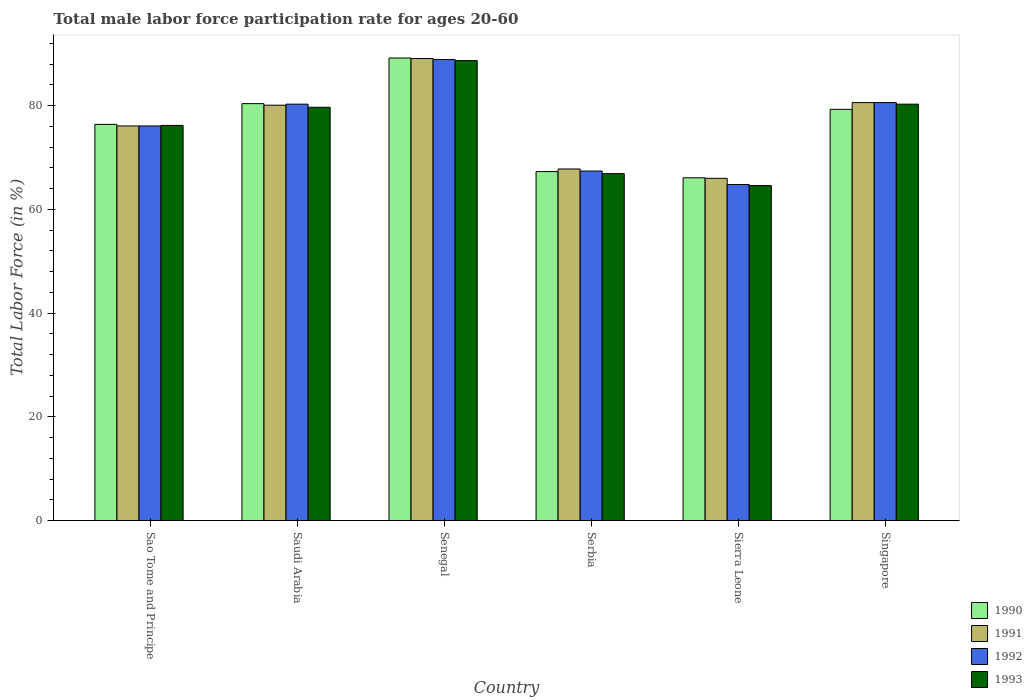Are the number of bars on each tick of the X-axis equal?
Ensure brevity in your answer.  Yes. What is the label of the 5th group of bars from the left?
Give a very brief answer. Sierra Leone. What is the male labor force participation rate in 1991 in Singapore?
Offer a very short reply. 80.6. Across all countries, what is the maximum male labor force participation rate in 1991?
Your answer should be compact. 89.1. Across all countries, what is the minimum male labor force participation rate in 1990?
Your answer should be compact. 66.1. In which country was the male labor force participation rate in 1990 maximum?
Keep it short and to the point. Senegal. In which country was the male labor force participation rate in 1993 minimum?
Make the answer very short. Sierra Leone. What is the total male labor force participation rate in 1993 in the graph?
Ensure brevity in your answer.  456.4. What is the difference between the male labor force participation rate in 1991 in Sao Tome and Principe and that in Sierra Leone?
Make the answer very short. 10.1. What is the difference between the male labor force participation rate in 1991 in Saudi Arabia and the male labor force participation rate in 1993 in Serbia?
Your answer should be very brief. 13.2. What is the average male labor force participation rate in 1993 per country?
Your answer should be compact. 76.07. What is the difference between the male labor force participation rate of/in 1990 and male labor force participation rate of/in 1991 in Singapore?
Ensure brevity in your answer.  -1.3. In how many countries, is the male labor force participation rate in 1992 greater than 56 %?
Your answer should be very brief. 6. What is the ratio of the male labor force participation rate in 1991 in Saudi Arabia to that in Serbia?
Your answer should be compact. 1.18. What is the difference between the highest and the second highest male labor force participation rate in 1993?
Provide a short and direct response. 8.4. What is the difference between the highest and the lowest male labor force participation rate in 1993?
Offer a very short reply. 24.1. In how many countries, is the male labor force participation rate in 1990 greater than the average male labor force participation rate in 1990 taken over all countries?
Give a very brief answer. 3. What does the 4th bar from the left in Singapore represents?
Make the answer very short. 1993. What does the 2nd bar from the right in Sierra Leone represents?
Offer a terse response. 1992. How many countries are there in the graph?
Provide a short and direct response. 6. What is the difference between two consecutive major ticks on the Y-axis?
Offer a terse response. 20. Are the values on the major ticks of Y-axis written in scientific E-notation?
Your answer should be very brief. No. Does the graph contain any zero values?
Your answer should be very brief. No. How many legend labels are there?
Provide a succinct answer. 4. How are the legend labels stacked?
Give a very brief answer. Vertical. What is the title of the graph?
Give a very brief answer. Total male labor force participation rate for ages 20-60. What is the label or title of the Y-axis?
Your response must be concise. Total Labor Force (in %). What is the Total Labor Force (in %) in 1990 in Sao Tome and Principe?
Provide a short and direct response. 76.4. What is the Total Labor Force (in %) in 1991 in Sao Tome and Principe?
Offer a terse response. 76.1. What is the Total Labor Force (in %) of 1992 in Sao Tome and Principe?
Offer a terse response. 76.1. What is the Total Labor Force (in %) in 1993 in Sao Tome and Principe?
Your answer should be very brief. 76.2. What is the Total Labor Force (in %) in 1990 in Saudi Arabia?
Provide a succinct answer. 80.4. What is the Total Labor Force (in %) of 1991 in Saudi Arabia?
Offer a very short reply. 80.1. What is the Total Labor Force (in %) of 1992 in Saudi Arabia?
Your answer should be very brief. 80.3. What is the Total Labor Force (in %) in 1993 in Saudi Arabia?
Offer a terse response. 79.7. What is the Total Labor Force (in %) in 1990 in Senegal?
Offer a terse response. 89.2. What is the Total Labor Force (in %) of 1991 in Senegal?
Your response must be concise. 89.1. What is the Total Labor Force (in %) of 1992 in Senegal?
Make the answer very short. 88.9. What is the Total Labor Force (in %) in 1993 in Senegal?
Make the answer very short. 88.7. What is the Total Labor Force (in %) of 1990 in Serbia?
Keep it short and to the point. 67.3. What is the Total Labor Force (in %) in 1991 in Serbia?
Offer a very short reply. 67.8. What is the Total Labor Force (in %) of 1992 in Serbia?
Make the answer very short. 67.4. What is the Total Labor Force (in %) in 1993 in Serbia?
Your response must be concise. 66.9. What is the Total Labor Force (in %) of 1990 in Sierra Leone?
Offer a terse response. 66.1. What is the Total Labor Force (in %) of 1992 in Sierra Leone?
Your answer should be compact. 64.8. What is the Total Labor Force (in %) in 1993 in Sierra Leone?
Ensure brevity in your answer.  64.6. What is the Total Labor Force (in %) in 1990 in Singapore?
Offer a very short reply. 79.3. What is the Total Labor Force (in %) of 1991 in Singapore?
Your answer should be very brief. 80.6. What is the Total Labor Force (in %) of 1992 in Singapore?
Your answer should be compact. 80.6. What is the Total Labor Force (in %) in 1993 in Singapore?
Your response must be concise. 80.3. Across all countries, what is the maximum Total Labor Force (in %) of 1990?
Offer a terse response. 89.2. Across all countries, what is the maximum Total Labor Force (in %) of 1991?
Provide a short and direct response. 89.1. Across all countries, what is the maximum Total Labor Force (in %) in 1992?
Provide a short and direct response. 88.9. Across all countries, what is the maximum Total Labor Force (in %) in 1993?
Provide a short and direct response. 88.7. Across all countries, what is the minimum Total Labor Force (in %) in 1990?
Make the answer very short. 66.1. Across all countries, what is the minimum Total Labor Force (in %) in 1991?
Keep it short and to the point. 66. Across all countries, what is the minimum Total Labor Force (in %) of 1992?
Your answer should be compact. 64.8. Across all countries, what is the minimum Total Labor Force (in %) in 1993?
Give a very brief answer. 64.6. What is the total Total Labor Force (in %) of 1990 in the graph?
Offer a terse response. 458.7. What is the total Total Labor Force (in %) in 1991 in the graph?
Provide a short and direct response. 459.7. What is the total Total Labor Force (in %) in 1992 in the graph?
Provide a short and direct response. 458.1. What is the total Total Labor Force (in %) in 1993 in the graph?
Ensure brevity in your answer.  456.4. What is the difference between the Total Labor Force (in %) of 1990 in Sao Tome and Principe and that in Saudi Arabia?
Your answer should be compact. -4. What is the difference between the Total Labor Force (in %) in 1991 in Sao Tome and Principe and that in Senegal?
Give a very brief answer. -13. What is the difference between the Total Labor Force (in %) of 1992 in Sao Tome and Principe and that in Senegal?
Your response must be concise. -12.8. What is the difference between the Total Labor Force (in %) in 1993 in Sao Tome and Principe and that in Senegal?
Make the answer very short. -12.5. What is the difference between the Total Labor Force (in %) of 1990 in Sao Tome and Principe and that in Serbia?
Give a very brief answer. 9.1. What is the difference between the Total Labor Force (in %) in 1991 in Sao Tome and Principe and that in Serbia?
Your answer should be very brief. 8.3. What is the difference between the Total Labor Force (in %) of 1993 in Sao Tome and Principe and that in Serbia?
Offer a very short reply. 9.3. What is the difference between the Total Labor Force (in %) in 1990 in Sao Tome and Principe and that in Singapore?
Offer a terse response. -2.9. What is the difference between the Total Labor Force (in %) in 1993 in Sao Tome and Principe and that in Singapore?
Ensure brevity in your answer.  -4.1. What is the difference between the Total Labor Force (in %) of 1990 in Saudi Arabia and that in Senegal?
Provide a short and direct response. -8.8. What is the difference between the Total Labor Force (in %) in 1992 in Saudi Arabia and that in Senegal?
Provide a short and direct response. -8.6. What is the difference between the Total Labor Force (in %) of 1993 in Saudi Arabia and that in Senegal?
Your response must be concise. -9. What is the difference between the Total Labor Force (in %) in 1992 in Saudi Arabia and that in Serbia?
Offer a terse response. 12.9. What is the difference between the Total Labor Force (in %) in 1993 in Saudi Arabia and that in Serbia?
Offer a very short reply. 12.8. What is the difference between the Total Labor Force (in %) of 1990 in Saudi Arabia and that in Sierra Leone?
Offer a terse response. 14.3. What is the difference between the Total Labor Force (in %) of 1992 in Saudi Arabia and that in Sierra Leone?
Your answer should be very brief. 15.5. What is the difference between the Total Labor Force (in %) of 1991 in Saudi Arabia and that in Singapore?
Provide a succinct answer. -0.5. What is the difference between the Total Labor Force (in %) of 1990 in Senegal and that in Serbia?
Provide a short and direct response. 21.9. What is the difference between the Total Labor Force (in %) in 1991 in Senegal and that in Serbia?
Give a very brief answer. 21.3. What is the difference between the Total Labor Force (in %) in 1993 in Senegal and that in Serbia?
Your answer should be compact. 21.8. What is the difference between the Total Labor Force (in %) of 1990 in Senegal and that in Sierra Leone?
Your answer should be very brief. 23.1. What is the difference between the Total Labor Force (in %) of 1991 in Senegal and that in Sierra Leone?
Your response must be concise. 23.1. What is the difference between the Total Labor Force (in %) of 1992 in Senegal and that in Sierra Leone?
Your answer should be very brief. 24.1. What is the difference between the Total Labor Force (in %) in 1993 in Senegal and that in Sierra Leone?
Offer a terse response. 24.1. What is the difference between the Total Labor Force (in %) in 1990 in Serbia and that in Sierra Leone?
Offer a very short reply. 1.2. What is the difference between the Total Labor Force (in %) of 1992 in Serbia and that in Sierra Leone?
Give a very brief answer. 2.6. What is the difference between the Total Labor Force (in %) in 1993 in Serbia and that in Sierra Leone?
Offer a terse response. 2.3. What is the difference between the Total Labor Force (in %) of 1992 in Serbia and that in Singapore?
Your answer should be very brief. -13.2. What is the difference between the Total Labor Force (in %) in 1993 in Serbia and that in Singapore?
Provide a short and direct response. -13.4. What is the difference between the Total Labor Force (in %) of 1990 in Sierra Leone and that in Singapore?
Keep it short and to the point. -13.2. What is the difference between the Total Labor Force (in %) in 1991 in Sierra Leone and that in Singapore?
Your answer should be very brief. -14.6. What is the difference between the Total Labor Force (in %) of 1992 in Sierra Leone and that in Singapore?
Provide a short and direct response. -15.8. What is the difference between the Total Labor Force (in %) of 1993 in Sierra Leone and that in Singapore?
Provide a succinct answer. -15.7. What is the difference between the Total Labor Force (in %) of 1990 in Sao Tome and Principe and the Total Labor Force (in %) of 1993 in Saudi Arabia?
Keep it short and to the point. -3.3. What is the difference between the Total Labor Force (in %) of 1992 in Sao Tome and Principe and the Total Labor Force (in %) of 1993 in Saudi Arabia?
Your answer should be compact. -3.6. What is the difference between the Total Labor Force (in %) in 1990 in Sao Tome and Principe and the Total Labor Force (in %) in 1992 in Senegal?
Offer a terse response. -12.5. What is the difference between the Total Labor Force (in %) of 1991 in Sao Tome and Principe and the Total Labor Force (in %) of 1993 in Senegal?
Your answer should be compact. -12.6. What is the difference between the Total Labor Force (in %) in 1992 in Sao Tome and Principe and the Total Labor Force (in %) in 1993 in Senegal?
Make the answer very short. -12.6. What is the difference between the Total Labor Force (in %) in 1990 in Sao Tome and Principe and the Total Labor Force (in %) in 1992 in Serbia?
Offer a terse response. 9. What is the difference between the Total Labor Force (in %) of 1990 in Sao Tome and Principe and the Total Labor Force (in %) of 1993 in Serbia?
Your answer should be compact. 9.5. What is the difference between the Total Labor Force (in %) in 1991 in Sao Tome and Principe and the Total Labor Force (in %) in 1992 in Serbia?
Provide a succinct answer. 8.7. What is the difference between the Total Labor Force (in %) in 1992 in Sao Tome and Principe and the Total Labor Force (in %) in 1993 in Serbia?
Keep it short and to the point. 9.2. What is the difference between the Total Labor Force (in %) of 1990 in Sao Tome and Principe and the Total Labor Force (in %) of 1991 in Sierra Leone?
Your answer should be compact. 10.4. What is the difference between the Total Labor Force (in %) in 1990 in Sao Tome and Principe and the Total Labor Force (in %) in 1993 in Sierra Leone?
Offer a terse response. 11.8. What is the difference between the Total Labor Force (in %) of 1990 in Sao Tome and Principe and the Total Labor Force (in %) of 1991 in Singapore?
Your answer should be compact. -4.2. What is the difference between the Total Labor Force (in %) in 1990 in Sao Tome and Principe and the Total Labor Force (in %) in 1993 in Singapore?
Your answer should be very brief. -3.9. What is the difference between the Total Labor Force (in %) of 1991 in Sao Tome and Principe and the Total Labor Force (in %) of 1992 in Singapore?
Offer a terse response. -4.5. What is the difference between the Total Labor Force (in %) in 1990 in Saudi Arabia and the Total Labor Force (in %) in 1991 in Senegal?
Make the answer very short. -8.7. What is the difference between the Total Labor Force (in %) of 1990 in Saudi Arabia and the Total Labor Force (in %) of 1992 in Senegal?
Offer a very short reply. -8.5. What is the difference between the Total Labor Force (in %) in 1990 in Saudi Arabia and the Total Labor Force (in %) in 1993 in Senegal?
Your response must be concise. -8.3. What is the difference between the Total Labor Force (in %) of 1990 in Saudi Arabia and the Total Labor Force (in %) of 1991 in Serbia?
Your answer should be very brief. 12.6. What is the difference between the Total Labor Force (in %) of 1990 in Saudi Arabia and the Total Labor Force (in %) of 1993 in Serbia?
Provide a short and direct response. 13.5. What is the difference between the Total Labor Force (in %) in 1991 in Saudi Arabia and the Total Labor Force (in %) in 1992 in Serbia?
Make the answer very short. 12.7. What is the difference between the Total Labor Force (in %) in 1992 in Saudi Arabia and the Total Labor Force (in %) in 1993 in Serbia?
Your answer should be compact. 13.4. What is the difference between the Total Labor Force (in %) of 1990 in Saudi Arabia and the Total Labor Force (in %) of 1991 in Sierra Leone?
Keep it short and to the point. 14.4. What is the difference between the Total Labor Force (in %) in 1990 in Saudi Arabia and the Total Labor Force (in %) in 1992 in Sierra Leone?
Provide a succinct answer. 15.6. What is the difference between the Total Labor Force (in %) of 1991 in Saudi Arabia and the Total Labor Force (in %) of 1992 in Sierra Leone?
Provide a succinct answer. 15.3. What is the difference between the Total Labor Force (in %) in 1991 in Saudi Arabia and the Total Labor Force (in %) in 1993 in Sierra Leone?
Your answer should be compact. 15.5. What is the difference between the Total Labor Force (in %) in 1990 in Saudi Arabia and the Total Labor Force (in %) in 1992 in Singapore?
Your answer should be compact. -0.2. What is the difference between the Total Labor Force (in %) of 1990 in Saudi Arabia and the Total Labor Force (in %) of 1993 in Singapore?
Provide a short and direct response. 0.1. What is the difference between the Total Labor Force (in %) in 1990 in Senegal and the Total Labor Force (in %) in 1991 in Serbia?
Offer a very short reply. 21.4. What is the difference between the Total Labor Force (in %) of 1990 in Senegal and the Total Labor Force (in %) of 1992 in Serbia?
Offer a very short reply. 21.8. What is the difference between the Total Labor Force (in %) of 1990 in Senegal and the Total Labor Force (in %) of 1993 in Serbia?
Make the answer very short. 22.3. What is the difference between the Total Labor Force (in %) in 1991 in Senegal and the Total Labor Force (in %) in 1992 in Serbia?
Your answer should be compact. 21.7. What is the difference between the Total Labor Force (in %) in 1992 in Senegal and the Total Labor Force (in %) in 1993 in Serbia?
Ensure brevity in your answer.  22. What is the difference between the Total Labor Force (in %) in 1990 in Senegal and the Total Labor Force (in %) in 1991 in Sierra Leone?
Provide a succinct answer. 23.2. What is the difference between the Total Labor Force (in %) in 1990 in Senegal and the Total Labor Force (in %) in 1992 in Sierra Leone?
Your answer should be very brief. 24.4. What is the difference between the Total Labor Force (in %) of 1990 in Senegal and the Total Labor Force (in %) of 1993 in Sierra Leone?
Your response must be concise. 24.6. What is the difference between the Total Labor Force (in %) of 1991 in Senegal and the Total Labor Force (in %) of 1992 in Sierra Leone?
Keep it short and to the point. 24.3. What is the difference between the Total Labor Force (in %) of 1992 in Senegal and the Total Labor Force (in %) of 1993 in Sierra Leone?
Give a very brief answer. 24.3. What is the difference between the Total Labor Force (in %) of 1990 in Senegal and the Total Labor Force (in %) of 1991 in Singapore?
Provide a short and direct response. 8.6. What is the difference between the Total Labor Force (in %) in 1990 in Senegal and the Total Labor Force (in %) in 1992 in Singapore?
Ensure brevity in your answer.  8.6. What is the difference between the Total Labor Force (in %) in 1990 in Senegal and the Total Labor Force (in %) in 1993 in Singapore?
Your response must be concise. 8.9. What is the difference between the Total Labor Force (in %) of 1991 in Senegal and the Total Labor Force (in %) of 1992 in Singapore?
Ensure brevity in your answer.  8.5. What is the difference between the Total Labor Force (in %) of 1992 in Senegal and the Total Labor Force (in %) of 1993 in Singapore?
Your answer should be compact. 8.6. What is the difference between the Total Labor Force (in %) in 1990 in Serbia and the Total Labor Force (in %) in 1991 in Singapore?
Offer a terse response. -13.3. What is the difference between the Total Labor Force (in %) in 1991 in Serbia and the Total Labor Force (in %) in 1992 in Singapore?
Your response must be concise. -12.8. What is the difference between the Total Labor Force (in %) of 1991 in Serbia and the Total Labor Force (in %) of 1993 in Singapore?
Provide a succinct answer. -12.5. What is the difference between the Total Labor Force (in %) in 1990 in Sierra Leone and the Total Labor Force (in %) in 1992 in Singapore?
Ensure brevity in your answer.  -14.5. What is the difference between the Total Labor Force (in %) in 1991 in Sierra Leone and the Total Labor Force (in %) in 1992 in Singapore?
Your response must be concise. -14.6. What is the difference between the Total Labor Force (in %) of 1991 in Sierra Leone and the Total Labor Force (in %) of 1993 in Singapore?
Provide a succinct answer. -14.3. What is the difference between the Total Labor Force (in %) of 1992 in Sierra Leone and the Total Labor Force (in %) of 1993 in Singapore?
Your answer should be very brief. -15.5. What is the average Total Labor Force (in %) of 1990 per country?
Provide a short and direct response. 76.45. What is the average Total Labor Force (in %) of 1991 per country?
Give a very brief answer. 76.62. What is the average Total Labor Force (in %) of 1992 per country?
Offer a terse response. 76.35. What is the average Total Labor Force (in %) of 1993 per country?
Give a very brief answer. 76.07. What is the difference between the Total Labor Force (in %) of 1990 and Total Labor Force (in %) of 1991 in Sao Tome and Principe?
Make the answer very short. 0.3. What is the difference between the Total Labor Force (in %) of 1991 and Total Labor Force (in %) of 1992 in Sao Tome and Principe?
Provide a succinct answer. 0. What is the difference between the Total Labor Force (in %) of 1992 and Total Labor Force (in %) of 1993 in Sao Tome and Principe?
Provide a short and direct response. -0.1. What is the difference between the Total Labor Force (in %) in 1990 and Total Labor Force (in %) in 1991 in Saudi Arabia?
Your answer should be very brief. 0.3. What is the difference between the Total Labor Force (in %) of 1991 and Total Labor Force (in %) of 1993 in Saudi Arabia?
Offer a terse response. 0.4. What is the difference between the Total Labor Force (in %) of 1992 and Total Labor Force (in %) of 1993 in Saudi Arabia?
Provide a succinct answer. 0.6. What is the difference between the Total Labor Force (in %) of 1991 and Total Labor Force (in %) of 1992 in Senegal?
Ensure brevity in your answer.  0.2. What is the difference between the Total Labor Force (in %) in 1991 and Total Labor Force (in %) in 1993 in Senegal?
Keep it short and to the point. 0.4. What is the difference between the Total Labor Force (in %) in 1990 and Total Labor Force (in %) in 1992 in Serbia?
Your answer should be very brief. -0.1. What is the difference between the Total Labor Force (in %) of 1992 and Total Labor Force (in %) of 1993 in Serbia?
Your answer should be very brief. 0.5. What is the difference between the Total Labor Force (in %) in 1990 and Total Labor Force (in %) in 1991 in Sierra Leone?
Provide a succinct answer. 0.1. What is the difference between the Total Labor Force (in %) in 1990 and Total Labor Force (in %) in 1992 in Sierra Leone?
Your response must be concise. 1.3. What is the difference between the Total Labor Force (in %) of 1991 and Total Labor Force (in %) of 1992 in Sierra Leone?
Offer a terse response. 1.2. What is the difference between the Total Labor Force (in %) of 1992 and Total Labor Force (in %) of 1993 in Sierra Leone?
Provide a succinct answer. 0.2. What is the difference between the Total Labor Force (in %) in 1990 and Total Labor Force (in %) in 1992 in Singapore?
Offer a very short reply. -1.3. What is the difference between the Total Labor Force (in %) of 1991 and Total Labor Force (in %) of 1992 in Singapore?
Provide a succinct answer. 0. What is the difference between the Total Labor Force (in %) of 1991 and Total Labor Force (in %) of 1993 in Singapore?
Give a very brief answer. 0.3. What is the difference between the Total Labor Force (in %) in 1992 and Total Labor Force (in %) in 1993 in Singapore?
Provide a short and direct response. 0.3. What is the ratio of the Total Labor Force (in %) in 1990 in Sao Tome and Principe to that in Saudi Arabia?
Offer a terse response. 0.95. What is the ratio of the Total Labor Force (in %) of 1991 in Sao Tome and Principe to that in Saudi Arabia?
Keep it short and to the point. 0.95. What is the ratio of the Total Labor Force (in %) in 1992 in Sao Tome and Principe to that in Saudi Arabia?
Keep it short and to the point. 0.95. What is the ratio of the Total Labor Force (in %) of 1993 in Sao Tome and Principe to that in Saudi Arabia?
Your response must be concise. 0.96. What is the ratio of the Total Labor Force (in %) of 1990 in Sao Tome and Principe to that in Senegal?
Offer a terse response. 0.86. What is the ratio of the Total Labor Force (in %) of 1991 in Sao Tome and Principe to that in Senegal?
Offer a terse response. 0.85. What is the ratio of the Total Labor Force (in %) of 1992 in Sao Tome and Principe to that in Senegal?
Your answer should be very brief. 0.86. What is the ratio of the Total Labor Force (in %) in 1993 in Sao Tome and Principe to that in Senegal?
Offer a very short reply. 0.86. What is the ratio of the Total Labor Force (in %) in 1990 in Sao Tome and Principe to that in Serbia?
Ensure brevity in your answer.  1.14. What is the ratio of the Total Labor Force (in %) of 1991 in Sao Tome and Principe to that in Serbia?
Keep it short and to the point. 1.12. What is the ratio of the Total Labor Force (in %) in 1992 in Sao Tome and Principe to that in Serbia?
Your response must be concise. 1.13. What is the ratio of the Total Labor Force (in %) of 1993 in Sao Tome and Principe to that in Serbia?
Your response must be concise. 1.14. What is the ratio of the Total Labor Force (in %) of 1990 in Sao Tome and Principe to that in Sierra Leone?
Your answer should be very brief. 1.16. What is the ratio of the Total Labor Force (in %) in 1991 in Sao Tome and Principe to that in Sierra Leone?
Your answer should be very brief. 1.15. What is the ratio of the Total Labor Force (in %) of 1992 in Sao Tome and Principe to that in Sierra Leone?
Your answer should be compact. 1.17. What is the ratio of the Total Labor Force (in %) of 1993 in Sao Tome and Principe to that in Sierra Leone?
Provide a short and direct response. 1.18. What is the ratio of the Total Labor Force (in %) in 1990 in Sao Tome and Principe to that in Singapore?
Provide a short and direct response. 0.96. What is the ratio of the Total Labor Force (in %) of 1991 in Sao Tome and Principe to that in Singapore?
Provide a short and direct response. 0.94. What is the ratio of the Total Labor Force (in %) of 1992 in Sao Tome and Principe to that in Singapore?
Provide a short and direct response. 0.94. What is the ratio of the Total Labor Force (in %) of 1993 in Sao Tome and Principe to that in Singapore?
Provide a short and direct response. 0.95. What is the ratio of the Total Labor Force (in %) of 1990 in Saudi Arabia to that in Senegal?
Provide a succinct answer. 0.9. What is the ratio of the Total Labor Force (in %) of 1991 in Saudi Arabia to that in Senegal?
Ensure brevity in your answer.  0.9. What is the ratio of the Total Labor Force (in %) of 1992 in Saudi Arabia to that in Senegal?
Your response must be concise. 0.9. What is the ratio of the Total Labor Force (in %) of 1993 in Saudi Arabia to that in Senegal?
Offer a very short reply. 0.9. What is the ratio of the Total Labor Force (in %) of 1990 in Saudi Arabia to that in Serbia?
Provide a short and direct response. 1.19. What is the ratio of the Total Labor Force (in %) of 1991 in Saudi Arabia to that in Serbia?
Keep it short and to the point. 1.18. What is the ratio of the Total Labor Force (in %) of 1992 in Saudi Arabia to that in Serbia?
Provide a short and direct response. 1.19. What is the ratio of the Total Labor Force (in %) in 1993 in Saudi Arabia to that in Serbia?
Your response must be concise. 1.19. What is the ratio of the Total Labor Force (in %) in 1990 in Saudi Arabia to that in Sierra Leone?
Your response must be concise. 1.22. What is the ratio of the Total Labor Force (in %) of 1991 in Saudi Arabia to that in Sierra Leone?
Make the answer very short. 1.21. What is the ratio of the Total Labor Force (in %) of 1992 in Saudi Arabia to that in Sierra Leone?
Give a very brief answer. 1.24. What is the ratio of the Total Labor Force (in %) of 1993 in Saudi Arabia to that in Sierra Leone?
Your answer should be very brief. 1.23. What is the ratio of the Total Labor Force (in %) in 1990 in Saudi Arabia to that in Singapore?
Offer a very short reply. 1.01. What is the ratio of the Total Labor Force (in %) in 1991 in Saudi Arabia to that in Singapore?
Your answer should be compact. 0.99. What is the ratio of the Total Labor Force (in %) in 1993 in Saudi Arabia to that in Singapore?
Provide a succinct answer. 0.99. What is the ratio of the Total Labor Force (in %) in 1990 in Senegal to that in Serbia?
Your response must be concise. 1.33. What is the ratio of the Total Labor Force (in %) in 1991 in Senegal to that in Serbia?
Offer a terse response. 1.31. What is the ratio of the Total Labor Force (in %) of 1992 in Senegal to that in Serbia?
Provide a succinct answer. 1.32. What is the ratio of the Total Labor Force (in %) in 1993 in Senegal to that in Serbia?
Your answer should be very brief. 1.33. What is the ratio of the Total Labor Force (in %) in 1990 in Senegal to that in Sierra Leone?
Provide a succinct answer. 1.35. What is the ratio of the Total Labor Force (in %) of 1991 in Senegal to that in Sierra Leone?
Keep it short and to the point. 1.35. What is the ratio of the Total Labor Force (in %) in 1992 in Senegal to that in Sierra Leone?
Give a very brief answer. 1.37. What is the ratio of the Total Labor Force (in %) in 1993 in Senegal to that in Sierra Leone?
Ensure brevity in your answer.  1.37. What is the ratio of the Total Labor Force (in %) of 1990 in Senegal to that in Singapore?
Your answer should be very brief. 1.12. What is the ratio of the Total Labor Force (in %) of 1991 in Senegal to that in Singapore?
Keep it short and to the point. 1.11. What is the ratio of the Total Labor Force (in %) of 1992 in Senegal to that in Singapore?
Keep it short and to the point. 1.1. What is the ratio of the Total Labor Force (in %) of 1993 in Senegal to that in Singapore?
Offer a terse response. 1.1. What is the ratio of the Total Labor Force (in %) of 1990 in Serbia to that in Sierra Leone?
Ensure brevity in your answer.  1.02. What is the ratio of the Total Labor Force (in %) in 1991 in Serbia to that in Sierra Leone?
Make the answer very short. 1.03. What is the ratio of the Total Labor Force (in %) of 1992 in Serbia to that in Sierra Leone?
Make the answer very short. 1.04. What is the ratio of the Total Labor Force (in %) in 1993 in Serbia to that in Sierra Leone?
Offer a very short reply. 1.04. What is the ratio of the Total Labor Force (in %) of 1990 in Serbia to that in Singapore?
Keep it short and to the point. 0.85. What is the ratio of the Total Labor Force (in %) in 1991 in Serbia to that in Singapore?
Provide a short and direct response. 0.84. What is the ratio of the Total Labor Force (in %) of 1992 in Serbia to that in Singapore?
Offer a very short reply. 0.84. What is the ratio of the Total Labor Force (in %) in 1993 in Serbia to that in Singapore?
Offer a very short reply. 0.83. What is the ratio of the Total Labor Force (in %) in 1990 in Sierra Leone to that in Singapore?
Offer a very short reply. 0.83. What is the ratio of the Total Labor Force (in %) in 1991 in Sierra Leone to that in Singapore?
Offer a terse response. 0.82. What is the ratio of the Total Labor Force (in %) of 1992 in Sierra Leone to that in Singapore?
Provide a short and direct response. 0.8. What is the ratio of the Total Labor Force (in %) of 1993 in Sierra Leone to that in Singapore?
Offer a terse response. 0.8. What is the difference between the highest and the second highest Total Labor Force (in %) of 1991?
Your response must be concise. 8.5. What is the difference between the highest and the lowest Total Labor Force (in %) in 1990?
Keep it short and to the point. 23.1. What is the difference between the highest and the lowest Total Labor Force (in %) of 1991?
Make the answer very short. 23.1. What is the difference between the highest and the lowest Total Labor Force (in %) of 1992?
Offer a very short reply. 24.1. What is the difference between the highest and the lowest Total Labor Force (in %) in 1993?
Your answer should be compact. 24.1. 